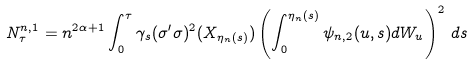<formula> <loc_0><loc_0><loc_500><loc_500>N ^ { n , 1 } _ { \tau } = n ^ { 2 \alpha + 1 } \int ^ { \tau } _ { 0 } \gamma _ { s } ( \sigma ^ { \prime } \sigma ) ^ { 2 } ( X _ { \eta _ { n } ( s ) } ) \left ( \int ^ { \eta _ { n } ( s ) } _ { 0 } \psi _ { n , 2 } ( u , s ) d W _ { u } \right ) ^ { 2 } \, d s</formula> 